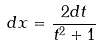Convert formula to latex. <formula><loc_0><loc_0><loc_500><loc_500>d x = \frac { 2 d t } { t ^ { 2 } + 1 }</formula> 